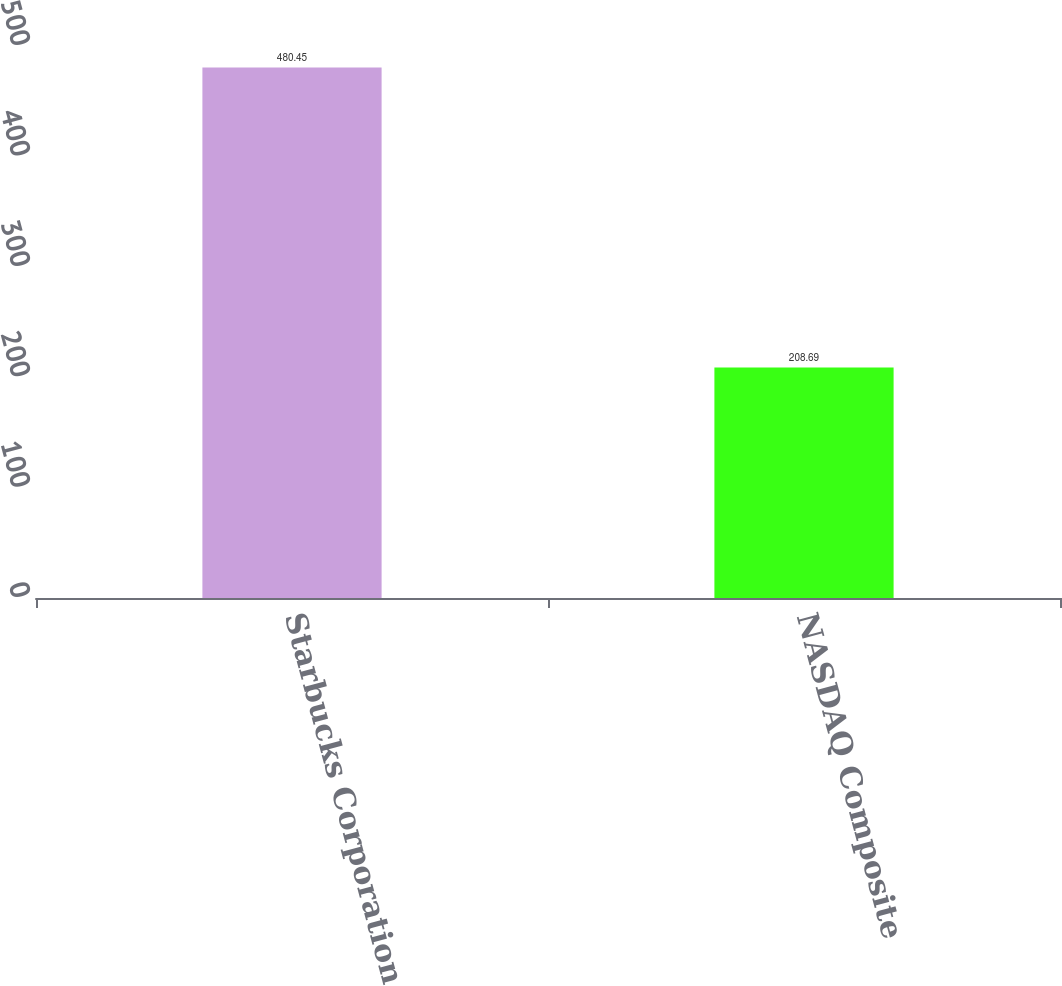Convert chart. <chart><loc_0><loc_0><loc_500><loc_500><bar_chart><fcel>Starbucks Corporation<fcel>NASDAQ Composite<nl><fcel>480.45<fcel>208.69<nl></chart> 